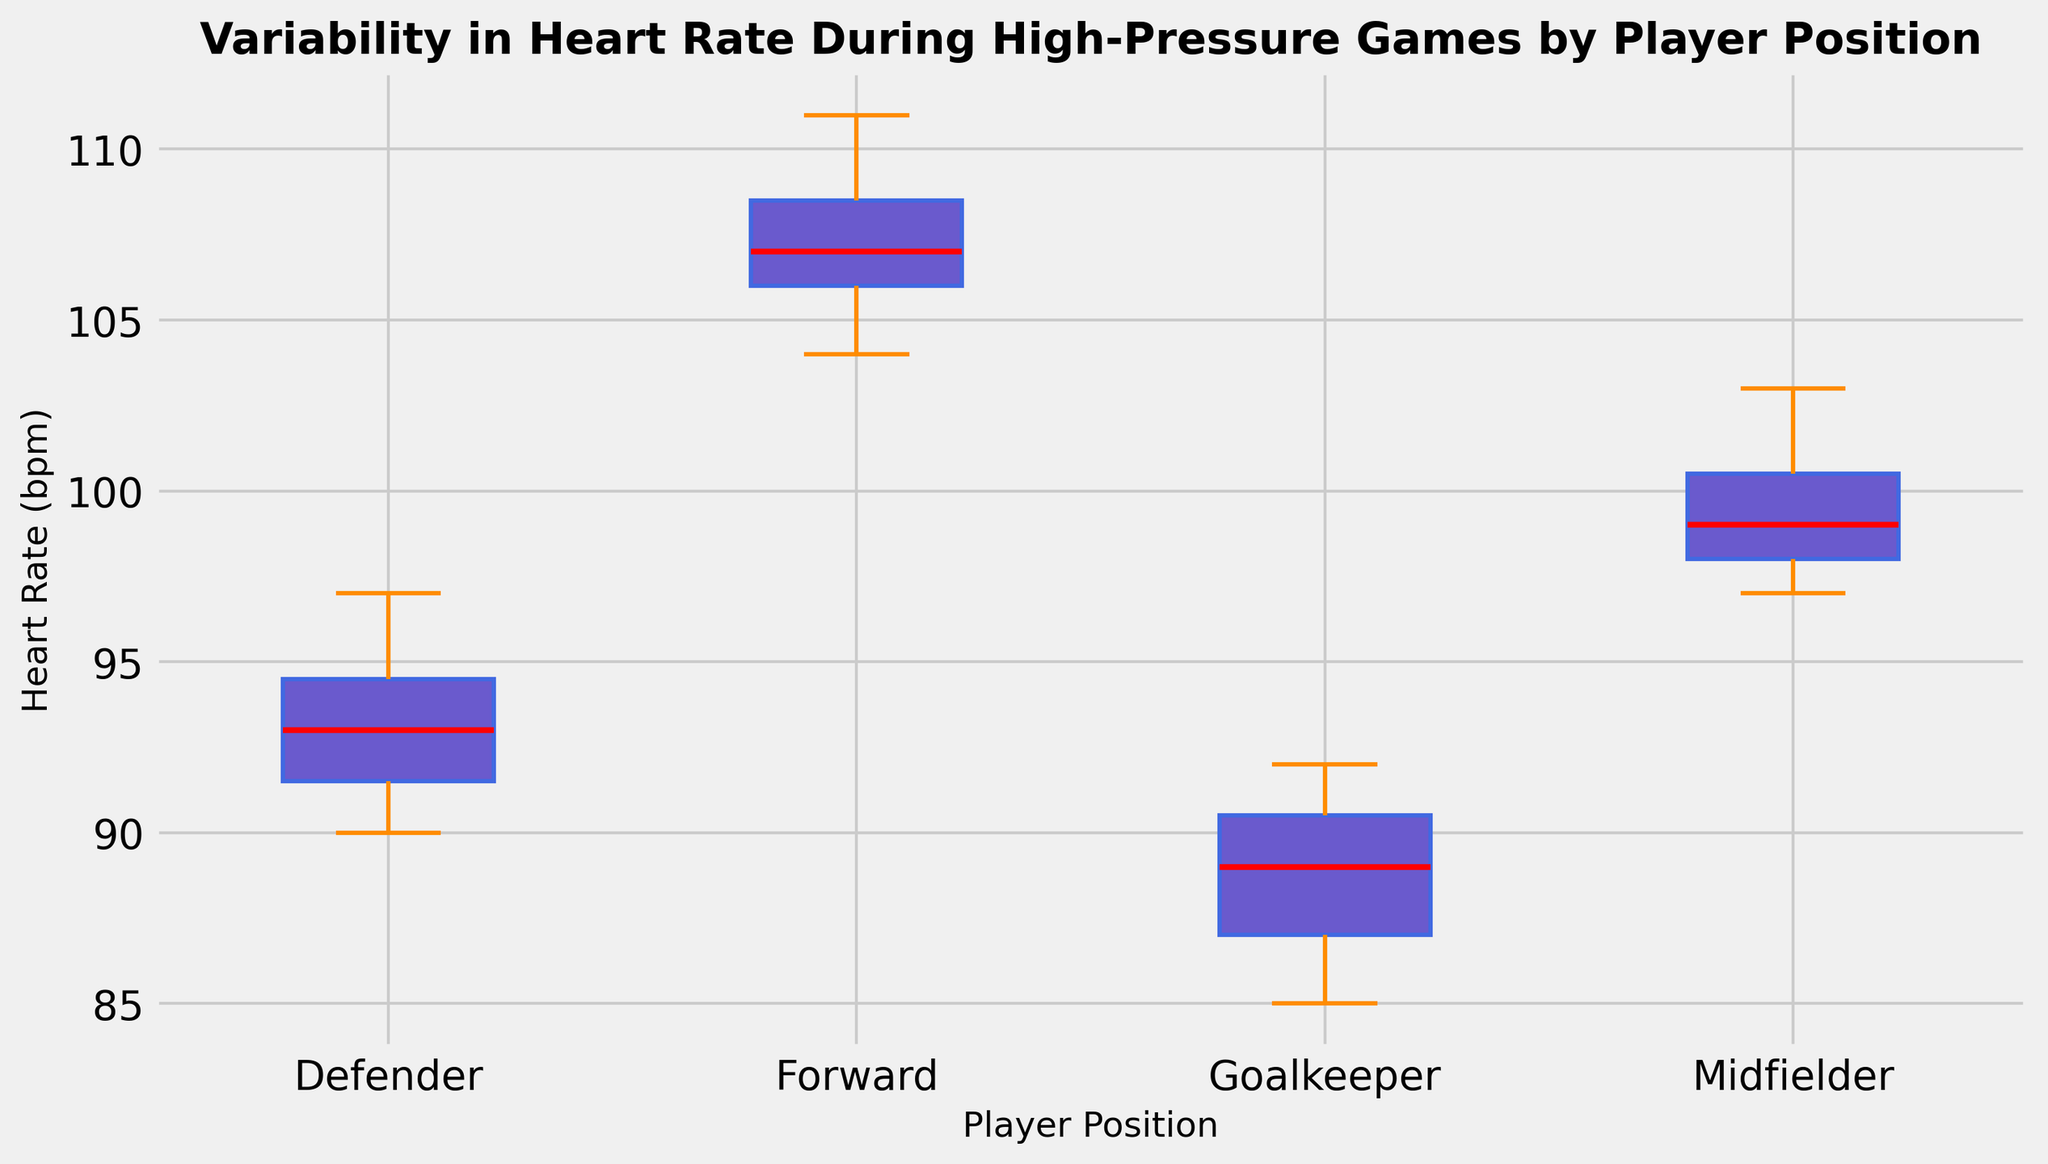Which player position has the highest median heart rate? To find the highest median heart rate, compare the red lines (which represent median values) in each box plot. The Forward position has the highest median.
Answer: Forward What is the range of heart rates for Goalkeepers? The range can be found by looking at the box plot ends (whiskers) for the Goalkeeper position. The minimum value is 85 and the maximum value is around 92. So, the range is 92 - 85.
Answer: 7 Which position has the widest interquartile range (IQR) for heart rates? The interquartile range (IQR) is determined by the distance between the bottom and top edges of the box (the first and third quartiles). By comparing all boxes, the Forward position has the widest IQR.
Answer: Forward Are there any outliers in the data, and for which positions? Outliers are represented by individual points outside the whiskers. By visual inspection, there are no individual points or symbols outside the whiskers for any positions.
Answer: No Which player position shows the smallest variability in heart rate? Variability is indicated by the size of the box and the length of the whiskers. The Goalkeeper position has the smallest combined size of box and whiskers, indicating the least variability.
Answer: Goalkeeper How does the median heart rate of Defenders compare to that of Midfielders? Compare the red lines (medians) for Defenders and Midfielders. The median for Defenders is slightly lower than that for Midfielders.
Answer: Lower What is the difference between the median heart rates of Forwards and Goalkeepers? Identify the median (red line) of Goalkeepers and Forwards. Forwards have a median of about 107 bpm, while Goalkeepers have a median of about 89 bpm. The difference is 107 - 89.
Answer: 18 bpm Which position shows the highest maximum heart rate? The maximum heart rate is indicated by the top of the whiskers. The Forward position reaches the highest heart rate, which is around 111 bpm.
Answer: Forward Does any player position have overlapping heart rate ranges with another? By comparing the ranges (whiskers) of all positions, you can see that there is an overlap between the ranges of Defenders and Midfielders, as well as between Midfielders and Forwards.
Answer: Yes _are the heart rates of Midfielders more than those of Goalkeepers on average?_ Comparing the position of the boxes, the box for Midfielders is entirely above the box for Goalkeepers, indicating that Midfielders generally have higher heart rates than Goalkeepers.
Answer: Yes 